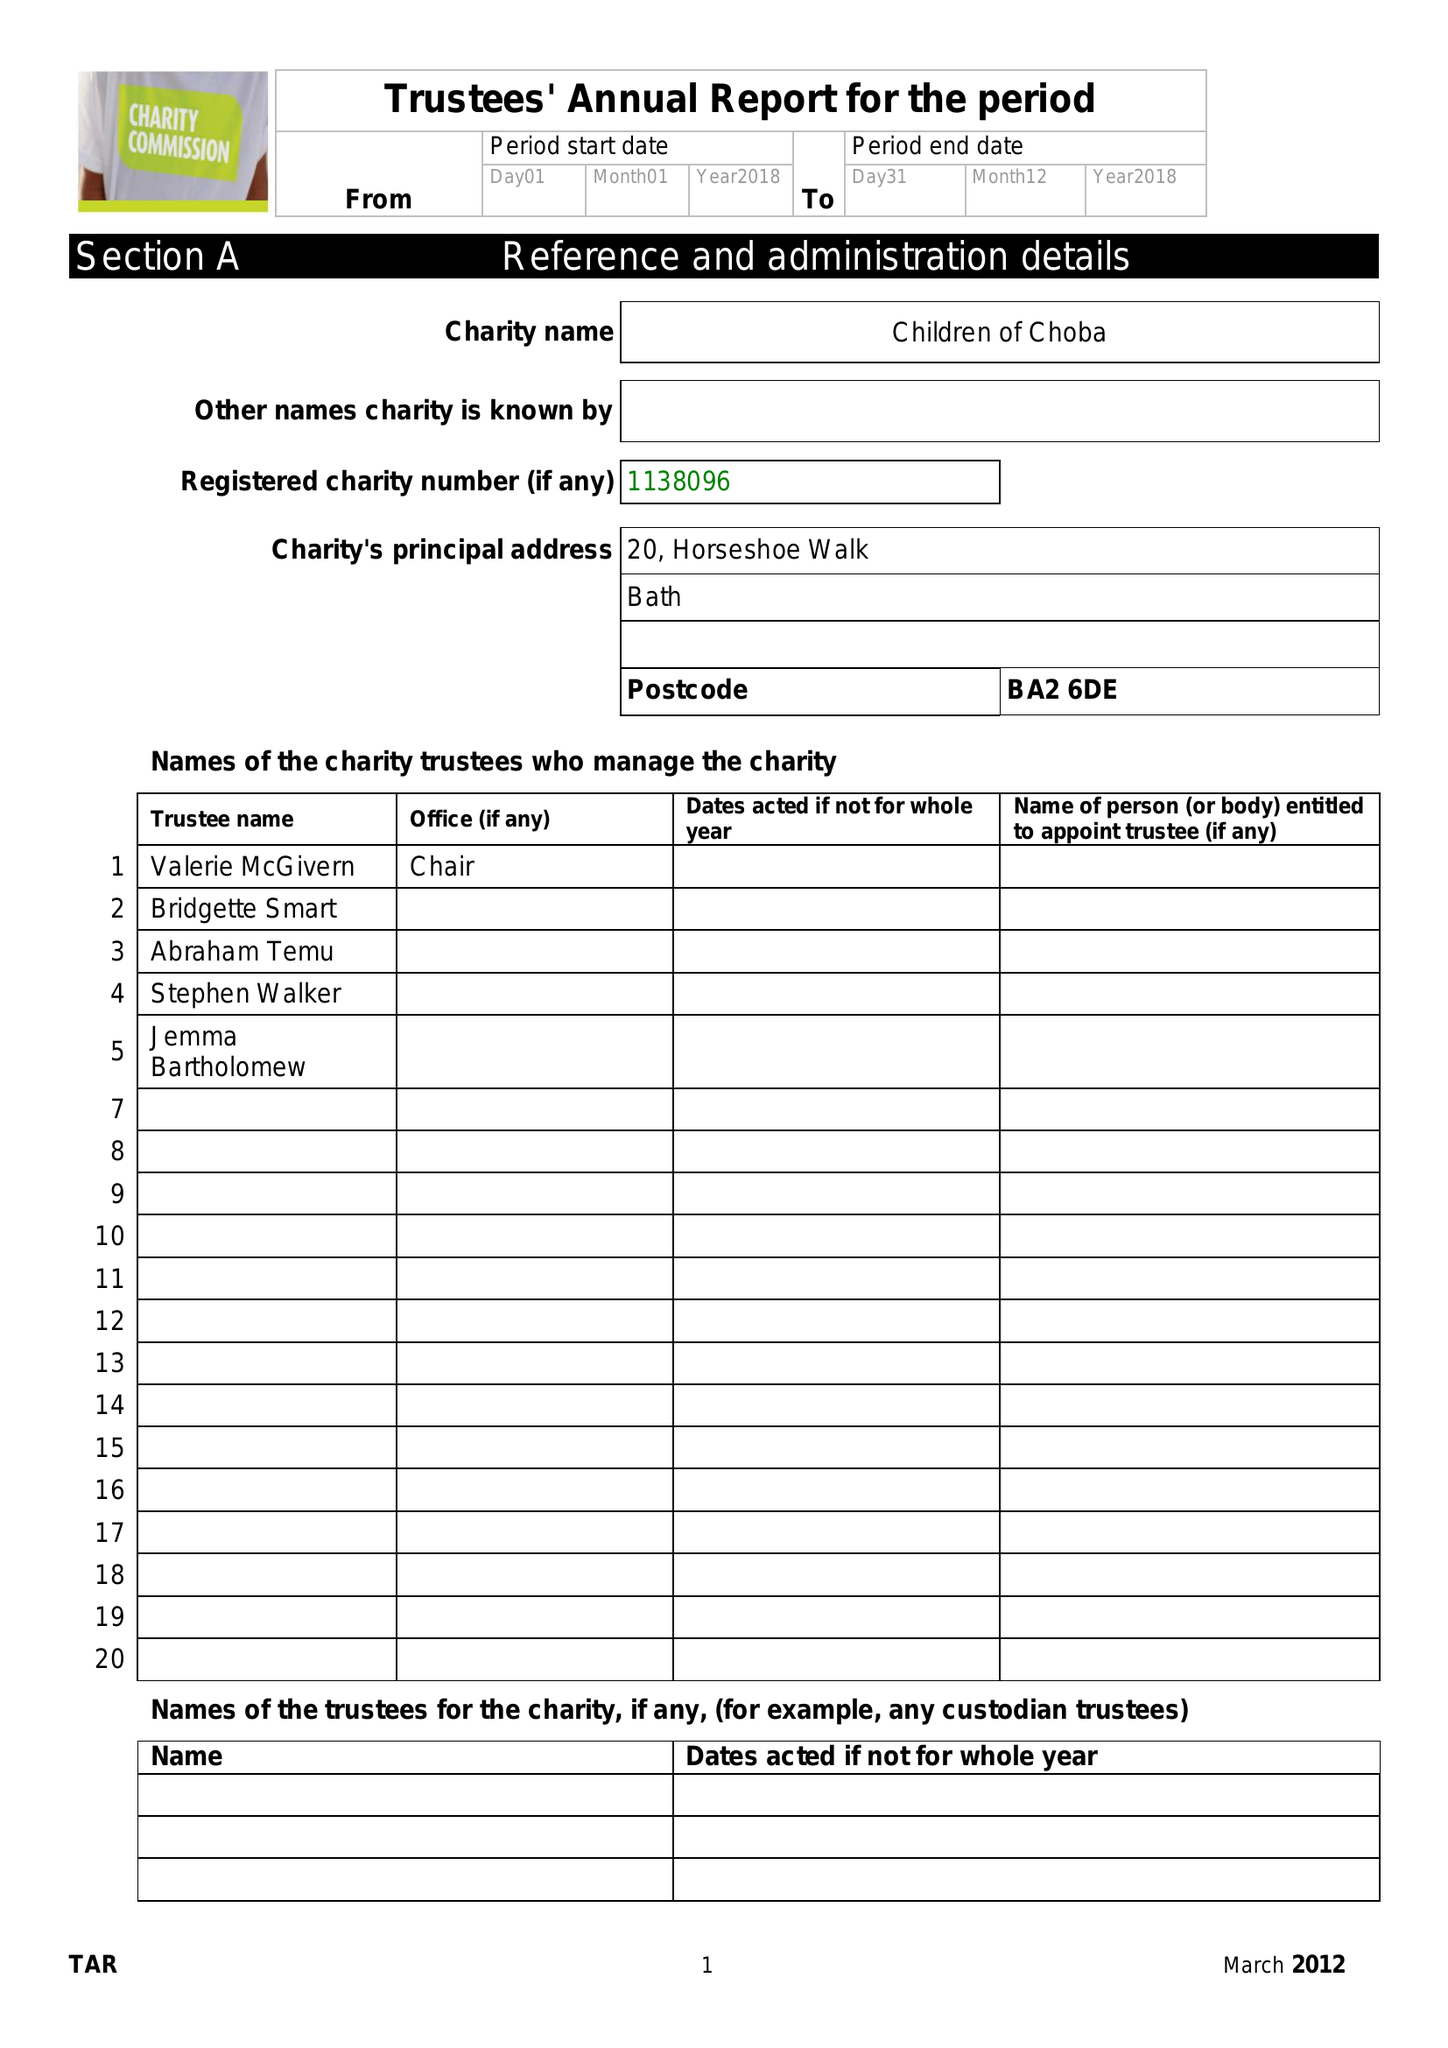What is the value for the charity_name?
Answer the question using a single word or phrase. Children Of Choba 